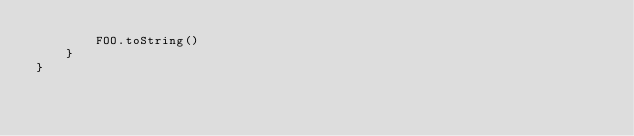<code> <loc_0><loc_0><loc_500><loc_500><_Kotlin_>        FOO.toString()
    }
}</code> 